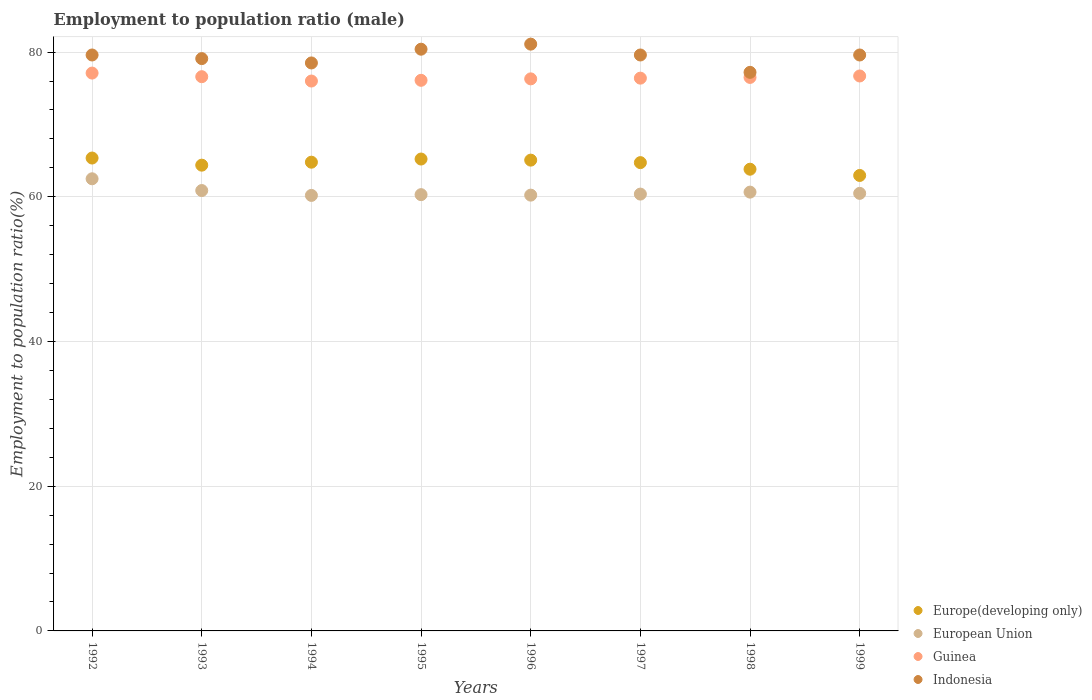How many different coloured dotlines are there?
Provide a succinct answer. 4. What is the employment to population ratio in European Union in 1994?
Your answer should be compact. 60.19. Across all years, what is the maximum employment to population ratio in Indonesia?
Your answer should be compact. 81.1. Across all years, what is the minimum employment to population ratio in Guinea?
Give a very brief answer. 76. In which year was the employment to population ratio in Indonesia minimum?
Ensure brevity in your answer.  1998. What is the total employment to population ratio in Europe(developing only) in the graph?
Keep it short and to the point. 516.29. What is the difference between the employment to population ratio in Indonesia in 1992 and the employment to population ratio in Europe(developing only) in 1997?
Give a very brief answer. 14.88. What is the average employment to population ratio in European Union per year?
Offer a very short reply. 60.7. In the year 1999, what is the difference between the employment to population ratio in Indonesia and employment to population ratio in Europe(developing only)?
Make the answer very short. 16.65. What is the ratio of the employment to population ratio in European Union in 1992 to that in 1995?
Make the answer very short. 1.04. Is the employment to population ratio in Guinea in 1996 less than that in 1998?
Keep it short and to the point. Yes. What is the difference between the highest and the second highest employment to population ratio in Guinea?
Your answer should be compact. 0.4. What is the difference between the highest and the lowest employment to population ratio in Guinea?
Provide a short and direct response. 1.1. Is the sum of the employment to population ratio in Guinea in 1995 and 1996 greater than the maximum employment to population ratio in Indonesia across all years?
Keep it short and to the point. Yes. Is it the case that in every year, the sum of the employment to population ratio in Europe(developing only) and employment to population ratio in Indonesia  is greater than the employment to population ratio in Guinea?
Provide a succinct answer. Yes. Does the employment to population ratio in Europe(developing only) monotonically increase over the years?
Make the answer very short. No. Is the employment to population ratio in European Union strictly greater than the employment to population ratio in Indonesia over the years?
Your answer should be very brief. No. Is the employment to population ratio in Guinea strictly less than the employment to population ratio in Indonesia over the years?
Ensure brevity in your answer.  Yes. What is the difference between two consecutive major ticks on the Y-axis?
Your answer should be compact. 20. Where does the legend appear in the graph?
Your answer should be very brief. Bottom right. What is the title of the graph?
Make the answer very short. Employment to population ratio (male). What is the label or title of the X-axis?
Keep it short and to the point. Years. What is the Employment to population ratio(%) of Europe(developing only) in 1992?
Provide a succinct answer. 65.36. What is the Employment to population ratio(%) in European Union in 1992?
Make the answer very short. 62.49. What is the Employment to population ratio(%) of Guinea in 1992?
Keep it short and to the point. 77.1. What is the Employment to population ratio(%) in Indonesia in 1992?
Your answer should be very brief. 79.6. What is the Employment to population ratio(%) in Europe(developing only) in 1993?
Your answer should be very brief. 64.37. What is the Employment to population ratio(%) in European Union in 1993?
Your answer should be very brief. 60.87. What is the Employment to population ratio(%) of Guinea in 1993?
Give a very brief answer. 76.6. What is the Employment to population ratio(%) of Indonesia in 1993?
Provide a succinct answer. 79.1. What is the Employment to population ratio(%) in Europe(developing only) in 1994?
Provide a succinct answer. 64.78. What is the Employment to population ratio(%) of European Union in 1994?
Your response must be concise. 60.19. What is the Employment to population ratio(%) in Indonesia in 1994?
Offer a terse response. 78.5. What is the Employment to population ratio(%) in Europe(developing only) in 1995?
Offer a very short reply. 65.22. What is the Employment to population ratio(%) of European Union in 1995?
Your answer should be very brief. 60.3. What is the Employment to population ratio(%) in Guinea in 1995?
Ensure brevity in your answer.  76.1. What is the Employment to population ratio(%) in Indonesia in 1995?
Provide a succinct answer. 80.4. What is the Employment to population ratio(%) of Europe(developing only) in 1996?
Provide a short and direct response. 65.07. What is the Employment to population ratio(%) of European Union in 1996?
Your answer should be very brief. 60.23. What is the Employment to population ratio(%) of Guinea in 1996?
Offer a very short reply. 76.3. What is the Employment to population ratio(%) in Indonesia in 1996?
Keep it short and to the point. 81.1. What is the Employment to population ratio(%) in Europe(developing only) in 1997?
Your answer should be compact. 64.72. What is the Employment to population ratio(%) in European Union in 1997?
Offer a very short reply. 60.37. What is the Employment to population ratio(%) of Guinea in 1997?
Provide a succinct answer. 76.4. What is the Employment to population ratio(%) in Indonesia in 1997?
Keep it short and to the point. 79.6. What is the Employment to population ratio(%) of Europe(developing only) in 1998?
Your answer should be compact. 63.81. What is the Employment to population ratio(%) in European Union in 1998?
Offer a very short reply. 60.65. What is the Employment to population ratio(%) of Guinea in 1998?
Provide a short and direct response. 76.5. What is the Employment to population ratio(%) of Indonesia in 1998?
Provide a succinct answer. 77.2. What is the Employment to population ratio(%) in Europe(developing only) in 1999?
Provide a succinct answer. 62.95. What is the Employment to population ratio(%) in European Union in 1999?
Provide a short and direct response. 60.48. What is the Employment to population ratio(%) of Guinea in 1999?
Your answer should be very brief. 76.7. What is the Employment to population ratio(%) of Indonesia in 1999?
Offer a terse response. 79.6. Across all years, what is the maximum Employment to population ratio(%) in Europe(developing only)?
Give a very brief answer. 65.36. Across all years, what is the maximum Employment to population ratio(%) in European Union?
Give a very brief answer. 62.49. Across all years, what is the maximum Employment to population ratio(%) in Guinea?
Provide a succinct answer. 77.1. Across all years, what is the maximum Employment to population ratio(%) in Indonesia?
Make the answer very short. 81.1. Across all years, what is the minimum Employment to population ratio(%) of Europe(developing only)?
Your response must be concise. 62.95. Across all years, what is the minimum Employment to population ratio(%) in European Union?
Provide a short and direct response. 60.19. Across all years, what is the minimum Employment to population ratio(%) in Guinea?
Give a very brief answer. 76. Across all years, what is the minimum Employment to population ratio(%) in Indonesia?
Offer a very short reply. 77.2. What is the total Employment to population ratio(%) in Europe(developing only) in the graph?
Your response must be concise. 516.29. What is the total Employment to population ratio(%) in European Union in the graph?
Give a very brief answer. 485.58. What is the total Employment to population ratio(%) of Guinea in the graph?
Provide a succinct answer. 611.7. What is the total Employment to population ratio(%) in Indonesia in the graph?
Give a very brief answer. 635.1. What is the difference between the Employment to population ratio(%) in European Union in 1992 and that in 1993?
Give a very brief answer. 1.62. What is the difference between the Employment to population ratio(%) of Indonesia in 1992 and that in 1993?
Ensure brevity in your answer.  0.5. What is the difference between the Employment to population ratio(%) of Europe(developing only) in 1992 and that in 1994?
Your answer should be very brief. 0.57. What is the difference between the Employment to population ratio(%) of European Union in 1992 and that in 1994?
Your response must be concise. 2.3. What is the difference between the Employment to population ratio(%) of Indonesia in 1992 and that in 1994?
Ensure brevity in your answer.  1.1. What is the difference between the Employment to population ratio(%) of Europe(developing only) in 1992 and that in 1995?
Provide a short and direct response. 0.14. What is the difference between the Employment to population ratio(%) in European Union in 1992 and that in 1995?
Your response must be concise. 2.19. What is the difference between the Employment to population ratio(%) of Europe(developing only) in 1992 and that in 1996?
Give a very brief answer. 0.29. What is the difference between the Employment to population ratio(%) in European Union in 1992 and that in 1996?
Provide a short and direct response. 2.26. What is the difference between the Employment to population ratio(%) in Guinea in 1992 and that in 1996?
Keep it short and to the point. 0.8. What is the difference between the Employment to population ratio(%) in Europe(developing only) in 1992 and that in 1997?
Provide a short and direct response. 0.63. What is the difference between the Employment to population ratio(%) of European Union in 1992 and that in 1997?
Offer a very short reply. 2.12. What is the difference between the Employment to population ratio(%) of Indonesia in 1992 and that in 1997?
Provide a succinct answer. 0. What is the difference between the Employment to population ratio(%) of Europe(developing only) in 1992 and that in 1998?
Keep it short and to the point. 1.54. What is the difference between the Employment to population ratio(%) in European Union in 1992 and that in 1998?
Your answer should be very brief. 1.84. What is the difference between the Employment to population ratio(%) of Guinea in 1992 and that in 1998?
Your answer should be compact. 0.6. What is the difference between the Employment to population ratio(%) in Indonesia in 1992 and that in 1998?
Your answer should be very brief. 2.4. What is the difference between the Employment to population ratio(%) of Europe(developing only) in 1992 and that in 1999?
Offer a very short reply. 2.41. What is the difference between the Employment to population ratio(%) of European Union in 1992 and that in 1999?
Give a very brief answer. 2.01. What is the difference between the Employment to population ratio(%) of Europe(developing only) in 1993 and that in 1994?
Keep it short and to the point. -0.41. What is the difference between the Employment to population ratio(%) in European Union in 1993 and that in 1994?
Offer a very short reply. 0.67. What is the difference between the Employment to population ratio(%) of Europe(developing only) in 1993 and that in 1995?
Provide a short and direct response. -0.85. What is the difference between the Employment to population ratio(%) of European Union in 1993 and that in 1995?
Offer a very short reply. 0.57. What is the difference between the Employment to population ratio(%) of Indonesia in 1993 and that in 1995?
Keep it short and to the point. -1.3. What is the difference between the Employment to population ratio(%) of Europe(developing only) in 1993 and that in 1996?
Give a very brief answer. -0.7. What is the difference between the Employment to population ratio(%) in European Union in 1993 and that in 1996?
Offer a very short reply. 0.63. What is the difference between the Employment to population ratio(%) of Guinea in 1993 and that in 1996?
Make the answer very short. 0.3. What is the difference between the Employment to population ratio(%) of Europe(developing only) in 1993 and that in 1997?
Provide a succinct answer. -0.35. What is the difference between the Employment to population ratio(%) in European Union in 1993 and that in 1997?
Provide a short and direct response. 0.49. What is the difference between the Employment to population ratio(%) in Guinea in 1993 and that in 1997?
Keep it short and to the point. 0.2. What is the difference between the Employment to population ratio(%) of Europe(developing only) in 1993 and that in 1998?
Provide a short and direct response. 0.56. What is the difference between the Employment to population ratio(%) in European Union in 1993 and that in 1998?
Your answer should be very brief. 0.22. What is the difference between the Employment to population ratio(%) of Guinea in 1993 and that in 1998?
Ensure brevity in your answer.  0.1. What is the difference between the Employment to population ratio(%) of Indonesia in 1993 and that in 1998?
Your response must be concise. 1.9. What is the difference between the Employment to population ratio(%) of Europe(developing only) in 1993 and that in 1999?
Give a very brief answer. 1.42. What is the difference between the Employment to population ratio(%) of European Union in 1993 and that in 1999?
Ensure brevity in your answer.  0.39. What is the difference between the Employment to population ratio(%) in Guinea in 1993 and that in 1999?
Your answer should be very brief. -0.1. What is the difference between the Employment to population ratio(%) of Europe(developing only) in 1994 and that in 1995?
Keep it short and to the point. -0.44. What is the difference between the Employment to population ratio(%) of European Union in 1994 and that in 1995?
Provide a short and direct response. -0.1. What is the difference between the Employment to population ratio(%) in Guinea in 1994 and that in 1995?
Ensure brevity in your answer.  -0.1. What is the difference between the Employment to population ratio(%) in Indonesia in 1994 and that in 1995?
Offer a very short reply. -1.9. What is the difference between the Employment to population ratio(%) in Europe(developing only) in 1994 and that in 1996?
Your response must be concise. -0.29. What is the difference between the Employment to population ratio(%) of European Union in 1994 and that in 1996?
Provide a succinct answer. -0.04. What is the difference between the Employment to population ratio(%) of Guinea in 1994 and that in 1996?
Provide a short and direct response. -0.3. What is the difference between the Employment to population ratio(%) in Indonesia in 1994 and that in 1996?
Keep it short and to the point. -2.6. What is the difference between the Employment to population ratio(%) of Europe(developing only) in 1994 and that in 1997?
Give a very brief answer. 0.06. What is the difference between the Employment to population ratio(%) in European Union in 1994 and that in 1997?
Offer a very short reply. -0.18. What is the difference between the Employment to population ratio(%) in Guinea in 1994 and that in 1997?
Offer a very short reply. -0.4. What is the difference between the Employment to population ratio(%) of Indonesia in 1994 and that in 1997?
Ensure brevity in your answer.  -1.1. What is the difference between the Employment to population ratio(%) of Europe(developing only) in 1994 and that in 1998?
Make the answer very short. 0.97. What is the difference between the Employment to population ratio(%) in European Union in 1994 and that in 1998?
Make the answer very short. -0.45. What is the difference between the Employment to population ratio(%) of Indonesia in 1994 and that in 1998?
Make the answer very short. 1.3. What is the difference between the Employment to population ratio(%) in Europe(developing only) in 1994 and that in 1999?
Your answer should be very brief. 1.83. What is the difference between the Employment to population ratio(%) of European Union in 1994 and that in 1999?
Offer a terse response. -0.28. What is the difference between the Employment to population ratio(%) in Guinea in 1994 and that in 1999?
Provide a succinct answer. -0.7. What is the difference between the Employment to population ratio(%) of Indonesia in 1994 and that in 1999?
Offer a terse response. -1.1. What is the difference between the Employment to population ratio(%) of Europe(developing only) in 1995 and that in 1996?
Offer a terse response. 0.15. What is the difference between the Employment to population ratio(%) of European Union in 1995 and that in 1996?
Your answer should be compact. 0.07. What is the difference between the Employment to population ratio(%) in Guinea in 1995 and that in 1996?
Offer a very short reply. -0.2. What is the difference between the Employment to population ratio(%) of Europe(developing only) in 1995 and that in 1997?
Provide a succinct answer. 0.5. What is the difference between the Employment to population ratio(%) of European Union in 1995 and that in 1997?
Your answer should be very brief. -0.08. What is the difference between the Employment to population ratio(%) in Europe(developing only) in 1995 and that in 1998?
Offer a terse response. 1.41. What is the difference between the Employment to population ratio(%) of European Union in 1995 and that in 1998?
Your answer should be very brief. -0.35. What is the difference between the Employment to population ratio(%) of Guinea in 1995 and that in 1998?
Ensure brevity in your answer.  -0.4. What is the difference between the Employment to population ratio(%) in Indonesia in 1995 and that in 1998?
Your response must be concise. 3.2. What is the difference between the Employment to population ratio(%) in Europe(developing only) in 1995 and that in 1999?
Ensure brevity in your answer.  2.27. What is the difference between the Employment to population ratio(%) in European Union in 1995 and that in 1999?
Provide a short and direct response. -0.18. What is the difference between the Employment to population ratio(%) of Guinea in 1995 and that in 1999?
Provide a succinct answer. -0.6. What is the difference between the Employment to population ratio(%) of Europe(developing only) in 1996 and that in 1997?
Your answer should be very brief. 0.35. What is the difference between the Employment to population ratio(%) in European Union in 1996 and that in 1997?
Keep it short and to the point. -0.14. What is the difference between the Employment to population ratio(%) of Indonesia in 1996 and that in 1997?
Keep it short and to the point. 1.5. What is the difference between the Employment to population ratio(%) of Europe(developing only) in 1996 and that in 1998?
Your answer should be very brief. 1.26. What is the difference between the Employment to population ratio(%) in European Union in 1996 and that in 1998?
Your answer should be very brief. -0.42. What is the difference between the Employment to population ratio(%) of Europe(developing only) in 1996 and that in 1999?
Your response must be concise. 2.12. What is the difference between the Employment to population ratio(%) in European Union in 1996 and that in 1999?
Your response must be concise. -0.25. What is the difference between the Employment to population ratio(%) of Indonesia in 1996 and that in 1999?
Give a very brief answer. 1.5. What is the difference between the Employment to population ratio(%) in Europe(developing only) in 1997 and that in 1998?
Offer a terse response. 0.91. What is the difference between the Employment to population ratio(%) in European Union in 1997 and that in 1998?
Offer a very short reply. -0.27. What is the difference between the Employment to population ratio(%) of Europe(developing only) in 1997 and that in 1999?
Provide a short and direct response. 1.77. What is the difference between the Employment to population ratio(%) of European Union in 1997 and that in 1999?
Provide a succinct answer. -0.1. What is the difference between the Employment to population ratio(%) of Indonesia in 1997 and that in 1999?
Keep it short and to the point. 0. What is the difference between the Employment to population ratio(%) of Europe(developing only) in 1998 and that in 1999?
Your answer should be compact. 0.86. What is the difference between the Employment to population ratio(%) of European Union in 1998 and that in 1999?
Offer a very short reply. 0.17. What is the difference between the Employment to population ratio(%) in Guinea in 1998 and that in 1999?
Make the answer very short. -0.2. What is the difference between the Employment to population ratio(%) in Indonesia in 1998 and that in 1999?
Offer a terse response. -2.4. What is the difference between the Employment to population ratio(%) in Europe(developing only) in 1992 and the Employment to population ratio(%) in European Union in 1993?
Your response must be concise. 4.49. What is the difference between the Employment to population ratio(%) of Europe(developing only) in 1992 and the Employment to population ratio(%) of Guinea in 1993?
Your answer should be compact. -11.24. What is the difference between the Employment to population ratio(%) of Europe(developing only) in 1992 and the Employment to population ratio(%) of Indonesia in 1993?
Keep it short and to the point. -13.74. What is the difference between the Employment to population ratio(%) in European Union in 1992 and the Employment to population ratio(%) in Guinea in 1993?
Your answer should be compact. -14.11. What is the difference between the Employment to population ratio(%) of European Union in 1992 and the Employment to population ratio(%) of Indonesia in 1993?
Offer a terse response. -16.61. What is the difference between the Employment to population ratio(%) of Europe(developing only) in 1992 and the Employment to population ratio(%) of European Union in 1994?
Ensure brevity in your answer.  5.16. What is the difference between the Employment to population ratio(%) of Europe(developing only) in 1992 and the Employment to population ratio(%) of Guinea in 1994?
Offer a terse response. -10.64. What is the difference between the Employment to population ratio(%) of Europe(developing only) in 1992 and the Employment to population ratio(%) of Indonesia in 1994?
Offer a terse response. -13.14. What is the difference between the Employment to population ratio(%) in European Union in 1992 and the Employment to population ratio(%) in Guinea in 1994?
Your answer should be very brief. -13.51. What is the difference between the Employment to population ratio(%) in European Union in 1992 and the Employment to population ratio(%) in Indonesia in 1994?
Your answer should be compact. -16.01. What is the difference between the Employment to population ratio(%) in Guinea in 1992 and the Employment to population ratio(%) in Indonesia in 1994?
Make the answer very short. -1.4. What is the difference between the Employment to population ratio(%) of Europe(developing only) in 1992 and the Employment to population ratio(%) of European Union in 1995?
Give a very brief answer. 5.06. What is the difference between the Employment to population ratio(%) of Europe(developing only) in 1992 and the Employment to population ratio(%) of Guinea in 1995?
Provide a succinct answer. -10.74. What is the difference between the Employment to population ratio(%) of Europe(developing only) in 1992 and the Employment to population ratio(%) of Indonesia in 1995?
Offer a very short reply. -15.04. What is the difference between the Employment to population ratio(%) in European Union in 1992 and the Employment to population ratio(%) in Guinea in 1995?
Your response must be concise. -13.61. What is the difference between the Employment to population ratio(%) in European Union in 1992 and the Employment to population ratio(%) in Indonesia in 1995?
Keep it short and to the point. -17.91. What is the difference between the Employment to population ratio(%) in Guinea in 1992 and the Employment to population ratio(%) in Indonesia in 1995?
Your answer should be compact. -3.3. What is the difference between the Employment to population ratio(%) of Europe(developing only) in 1992 and the Employment to population ratio(%) of European Union in 1996?
Provide a succinct answer. 5.13. What is the difference between the Employment to population ratio(%) of Europe(developing only) in 1992 and the Employment to population ratio(%) of Guinea in 1996?
Offer a very short reply. -10.94. What is the difference between the Employment to population ratio(%) of Europe(developing only) in 1992 and the Employment to population ratio(%) of Indonesia in 1996?
Your answer should be compact. -15.74. What is the difference between the Employment to population ratio(%) of European Union in 1992 and the Employment to population ratio(%) of Guinea in 1996?
Make the answer very short. -13.81. What is the difference between the Employment to population ratio(%) of European Union in 1992 and the Employment to population ratio(%) of Indonesia in 1996?
Provide a short and direct response. -18.61. What is the difference between the Employment to population ratio(%) in Europe(developing only) in 1992 and the Employment to population ratio(%) in European Union in 1997?
Make the answer very short. 4.98. What is the difference between the Employment to population ratio(%) of Europe(developing only) in 1992 and the Employment to population ratio(%) of Guinea in 1997?
Provide a succinct answer. -11.04. What is the difference between the Employment to population ratio(%) of Europe(developing only) in 1992 and the Employment to population ratio(%) of Indonesia in 1997?
Your response must be concise. -14.24. What is the difference between the Employment to population ratio(%) in European Union in 1992 and the Employment to population ratio(%) in Guinea in 1997?
Offer a terse response. -13.91. What is the difference between the Employment to population ratio(%) in European Union in 1992 and the Employment to population ratio(%) in Indonesia in 1997?
Your answer should be compact. -17.11. What is the difference between the Employment to population ratio(%) of Europe(developing only) in 1992 and the Employment to population ratio(%) of European Union in 1998?
Keep it short and to the point. 4.71. What is the difference between the Employment to population ratio(%) in Europe(developing only) in 1992 and the Employment to population ratio(%) in Guinea in 1998?
Provide a succinct answer. -11.14. What is the difference between the Employment to population ratio(%) of Europe(developing only) in 1992 and the Employment to population ratio(%) of Indonesia in 1998?
Offer a very short reply. -11.84. What is the difference between the Employment to population ratio(%) of European Union in 1992 and the Employment to population ratio(%) of Guinea in 1998?
Give a very brief answer. -14.01. What is the difference between the Employment to population ratio(%) of European Union in 1992 and the Employment to population ratio(%) of Indonesia in 1998?
Keep it short and to the point. -14.71. What is the difference between the Employment to population ratio(%) in Guinea in 1992 and the Employment to population ratio(%) in Indonesia in 1998?
Provide a succinct answer. -0.1. What is the difference between the Employment to population ratio(%) in Europe(developing only) in 1992 and the Employment to population ratio(%) in European Union in 1999?
Ensure brevity in your answer.  4.88. What is the difference between the Employment to population ratio(%) in Europe(developing only) in 1992 and the Employment to population ratio(%) in Guinea in 1999?
Provide a short and direct response. -11.34. What is the difference between the Employment to population ratio(%) in Europe(developing only) in 1992 and the Employment to population ratio(%) in Indonesia in 1999?
Your answer should be compact. -14.24. What is the difference between the Employment to population ratio(%) in European Union in 1992 and the Employment to population ratio(%) in Guinea in 1999?
Provide a succinct answer. -14.21. What is the difference between the Employment to population ratio(%) in European Union in 1992 and the Employment to population ratio(%) in Indonesia in 1999?
Provide a short and direct response. -17.11. What is the difference between the Employment to population ratio(%) of Europe(developing only) in 1993 and the Employment to population ratio(%) of European Union in 1994?
Make the answer very short. 4.18. What is the difference between the Employment to population ratio(%) in Europe(developing only) in 1993 and the Employment to population ratio(%) in Guinea in 1994?
Give a very brief answer. -11.63. What is the difference between the Employment to population ratio(%) of Europe(developing only) in 1993 and the Employment to population ratio(%) of Indonesia in 1994?
Your answer should be very brief. -14.13. What is the difference between the Employment to population ratio(%) in European Union in 1993 and the Employment to population ratio(%) in Guinea in 1994?
Keep it short and to the point. -15.13. What is the difference between the Employment to population ratio(%) in European Union in 1993 and the Employment to population ratio(%) in Indonesia in 1994?
Provide a short and direct response. -17.63. What is the difference between the Employment to population ratio(%) of Guinea in 1993 and the Employment to population ratio(%) of Indonesia in 1994?
Keep it short and to the point. -1.9. What is the difference between the Employment to population ratio(%) in Europe(developing only) in 1993 and the Employment to population ratio(%) in European Union in 1995?
Give a very brief answer. 4.08. What is the difference between the Employment to population ratio(%) of Europe(developing only) in 1993 and the Employment to population ratio(%) of Guinea in 1995?
Provide a succinct answer. -11.73. What is the difference between the Employment to population ratio(%) of Europe(developing only) in 1993 and the Employment to population ratio(%) of Indonesia in 1995?
Your answer should be compact. -16.03. What is the difference between the Employment to population ratio(%) in European Union in 1993 and the Employment to population ratio(%) in Guinea in 1995?
Your response must be concise. -15.23. What is the difference between the Employment to population ratio(%) in European Union in 1993 and the Employment to population ratio(%) in Indonesia in 1995?
Give a very brief answer. -19.53. What is the difference between the Employment to population ratio(%) in Europe(developing only) in 1993 and the Employment to population ratio(%) in European Union in 1996?
Offer a terse response. 4.14. What is the difference between the Employment to population ratio(%) in Europe(developing only) in 1993 and the Employment to population ratio(%) in Guinea in 1996?
Make the answer very short. -11.93. What is the difference between the Employment to population ratio(%) of Europe(developing only) in 1993 and the Employment to population ratio(%) of Indonesia in 1996?
Provide a succinct answer. -16.73. What is the difference between the Employment to population ratio(%) in European Union in 1993 and the Employment to population ratio(%) in Guinea in 1996?
Make the answer very short. -15.43. What is the difference between the Employment to population ratio(%) of European Union in 1993 and the Employment to population ratio(%) of Indonesia in 1996?
Provide a succinct answer. -20.23. What is the difference between the Employment to population ratio(%) of Guinea in 1993 and the Employment to population ratio(%) of Indonesia in 1996?
Ensure brevity in your answer.  -4.5. What is the difference between the Employment to population ratio(%) in Europe(developing only) in 1993 and the Employment to population ratio(%) in European Union in 1997?
Your response must be concise. 4. What is the difference between the Employment to population ratio(%) of Europe(developing only) in 1993 and the Employment to population ratio(%) of Guinea in 1997?
Your answer should be very brief. -12.03. What is the difference between the Employment to population ratio(%) of Europe(developing only) in 1993 and the Employment to population ratio(%) of Indonesia in 1997?
Offer a very short reply. -15.23. What is the difference between the Employment to population ratio(%) of European Union in 1993 and the Employment to population ratio(%) of Guinea in 1997?
Provide a short and direct response. -15.53. What is the difference between the Employment to population ratio(%) in European Union in 1993 and the Employment to population ratio(%) in Indonesia in 1997?
Your response must be concise. -18.73. What is the difference between the Employment to population ratio(%) of Guinea in 1993 and the Employment to population ratio(%) of Indonesia in 1997?
Your answer should be compact. -3. What is the difference between the Employment to population ratio(%) in Europe(developing only) in 1993 and the Employment to population ratio(%) in European Union in 1998?
Your answer should be compact. 3.73. What is the difference between the Employment to population ratio(%) of Europe(developing only) in 1993 and the Employment to population ratio(%) of Guinea in 1998?
Keep it short and to the point. -12.13. What is the difference between the Employment to population ratio(%) in Europe(developing only) in 1993 and the Employment to population ratio(%) in Indonesia in 1998?
Provide a succinct answer. -12.83. What is the difference between the Employment to population ratio(%) in European Union in 1993 and the Employment to population ratio(%) in Guinea in 1998?
Your response must be concise. -15.63. What is the difference between the Employment to population ratio(%) of European Union in 1993 and the Employment to population ratio(%) of Indonesia in 1998?
Your response must be concise. -16.33. What is the difference between the Employment to population ratio(%) of Guinea in 1993 and the Employment to population ratio(%) of Indonesia in 1998?
Provide a short and direct response. -0.6. What is the difference between the Employment to population ratio(%) in Europe(developing only) in 1993 and the Employment to population ratio(%) in European Union in 1999?
Your answer should be very brief. 3.9. What is the difference between the Employment to population ratio(%) of Europe(developing only) in 1993 and the Employment to population ratio(%) of Guinea in 1999?
Ensure brevity in your answer.  -12.33. What is the difference between the Employment to population ratio(%) in Europe(developing only) in 1993 and the Employment to population ratio(%) in Indonesia in 1999?
Make the answer very short. -15.23. What is the difference between the Employment to population ratio(%) in European Union in 1993 and the Employment to population ratio(%) in Guinea in 1999?
Make the answer very short. -15.83. What is the difference between the Employment to population ratio(%) in European Union in 1993 and the Employment to population ratio(%) in Indonesia in 1999?
Keep it short and to the point. -18.73. What is the difference between the Employment to population ratio(%) of Europe(developing only) in 1994 and the Employment to population ratio(%) of European Union in 1995?
Make the answer very short. 4.49. What is the difference between the Employment to population ratio(%) in Europe(developing only) in 1994 and the Employment to population ratio(%) in Guinea in 1995?
Offer a terse response. -11.32. What is the difference between the Employment to population ratio(%) of Europe(developing only) in 1994 and the Employment to population ratio(%) of Indonesia in 1995?
Your response must be concise. -15.62. What is the difference between the Employment to population ratio(%) of European Union in 1994 and the Employment to population ratio(%) of Guinea in 1995?
Provide a short and direct response. -15.91. What is the difference between the Employment to population ratio(%) of European Union in 1994 and the Employment to population ratio(%) of Indonesia in 1995?
Give a very brief answer. -20.21. What is the difference between the Employment to population ratio(%) of Europe(developing only) in 1994 and the Employment to population ratio(%) of European Union in 1996?
Keep it short and to the point. 4.55. What is the difference between the Employment to population ratio(%) of Europe(developing only) in 1994 and the Employment to population ratio(%) of Guinea in 1996?
Provide a short and direct response. -11.52. What is the difference between the Employment to population ratio(%) of Europe(developing only) in 1994 and the Employment to population ratio(%) of Indonesia in 1996?
Give a very brief answer. -16.32. What is the difference between the Employment to population ratio(%) in European Union in 1994 and the Employment to population ratio(%) in Guinea in 1996?
Make the answer very short. -16.11. What is the difference between the Employment to population ratio(%) of European Union in 1994 and the Employment to population ratio(%) of Indonesia in 1996?
Provide a succinct answer. -20.91. What is the difference between the Employment to population ratio(%) in Guinea in 1994 and the Employment to population ratio(%) in Indonesia in 1996?
Your answer should be very brief. -5.1. What is the difference between the Employment to population ratio(%) in Europe(developing only) in 1994 and the Employment to population ratio(%) in European Union in 1997?
Your answer should be compact. 4.41. What is the difference between the Employment to population ratio(%) of Europe(developing only) in 1994 and the Employment to population ratio(%) of Guinea in 1997?
Give a very brief answer. -11.62. What is the difference between the Employment to population ratio(%) of Europe(developing only) in 1994 and the Employment to population ratio(%) of Indonesia in 1997?
Provide a short and direct response. -14.82. What is the difference between the Employment to population ratio(%) in European Union in 1994 and the Employment to population ratio(%) in Guinea in 1997?
Provide a short and direct response. -16.21. What is the difference between the Employment to population ratio(%) in European Union in 1994 and the Employment to population ratio(%) in Indonesia in 1997?
Offer a very short reply. -19.41. What is the difference between the Employment to population ratio(%) in Europe(developing only) in 1994 and the Employment to population ratio(%) in European Union in 1998?
Ensure brevity in your answer.  4.14. What is the difference between the Employment to population ratio(%) in Europe(developing only) in 1994 and the Employment to population ratio(%) in Guinea in 1998?
Your response must be concise. -11.72. What is the difference between the Employment to population ratio(%) of Europe(developing only) in 1994 and the Employment to population ratio(%) of Indonesia in 1998?
Your response must be concise. -12.42. What is the difference between the Employment to population ratio(%) of European Union in 1994 and the Employment to population ratio(%) of Guinea in 1998?
Provide a short and direct response. -16.31. What is the difference between the Employment to population ratio(%) of European Union in 1994 and the Employment to population ratio(%) of Indonesia in 1998?
Provide a succinct answer. -17.01. What is the difference between the Employment to population ratio(%) of Europe(developing only) in 1994 and the Employment to population ratio(%) of European Union in 1999?
Your answer should be compact. 4.31. What is the difference between the Employment to population ratio(%) in Europe(developing only) in 1994 and the Employment to population ratio(%) in Guinea in 1999?
Provide a succinct answer. -11.92. What is the difference between the Employment to population ratio(%) of Europe(developing only) in 1994 and the Employment to population ratio(%) of Indonesia in 1999?
Give a very brief answer. -14.82. What is the difference between the Employment to population ratio(%) in European Union in 1994 and the Employment to population ratio(%) in Guinea in 1999?
Make the answer very short. -16.51. What is the difference between the Employment to population ratio(%) in European Union in 1994 and the Employment to population ratio(%) in Indonesia in 1999?
Keep it short and to the point. -19.41. What is the difference between the Employment to population ratio(%) of Guinea in 1994 and the Employment to population ratio(%) of Indonesia in 1999?
Your answer should be compact. -3.6. What is the difference between the Employment to population ratio(%) in Europe(developing only) in 1995 and the Employment to population ratio(%) in European Union in 1996?
Your response must be concise. 4.99. What is the difference between the Employment to population ratio(%) of Europe(developing only) in 1995 and the Employment to population ratio(%) of Guinea in 1996?
Offer a very short reply. -11.08. What is the difference between the Employment to population ratio(%) in Europe(developing only) in 1995 and the Employment to population ratio(%) in Indonesia in 1996?
Make the answer very short. -15.88. What is the difference between the Employment to population ratio(%) in European Union in 1995 and the Employment to population ratio(%) in Guinea in 1996?
Ensure brevity in your answer.  -16. What is the difference between the Employment to population ratio(%) in European Union in 1995 and the Employment to population ratio(%) in Indonesia in 1996?
Ensure brevity in your answer.  -20.8. What is the difference between the Employment to population ratio(%) of Europe(developing only) in 1995 and the Employment to population ratio(%) of European Union in 1997?
Keep it short and to the point. 4.85. What is the difference between the Employment to population ratio(%) of Europe(developing only) in 1995 and the Employment to population ratio(%) of Guinea in 1997?
Provide a succinct answer. -11.18. What is the difference between the Employment to population ratio(%) of Europe(developing only) in 1995 and the Employment to population ratio(%) of Indonesia in 1997?
Give a very brief answer. -14.38. What is the difference between the Employment to population ratio(%) of European Union in 1995 and the Employment to population ratio(%) of Guinea in 1997?
Ensure brevity in your answer.  -16.1. What is the difference between the Employment to population ratio(%) in European Union in 1995 and the Employment to population ratio(%) in Indonesia in 1997?
Keep it short and to the point. -19.3. What is the difference between the Employment to population ratio(%) in Europe(developing only) in 1995 and the Employment to population ratio(%) in European Union in 1998?
Offer a very short reply. 4.57. What is the difference between the Employment to population ratio(%) of Europe(developing only) in 1995 and the Employment to population ratio(%) of Guinea in 1998?
Provide a succinct answer. -11.28. What is the difference between the Employment to population ratio(%) of Europe(developing only) in 1995 and the Employment to population ratio(%) of Indonesia in 1998?
Your answer should be very brief. -11.98. What is the difference between the Employment to population ratio(%) in European Union in 1995 and the Employment to population ratio(%) in Guinea in 1998?
Offer a very short reply. -16.2. What is the difference between the Employment to population ratio(%) of European Union in 1995 and the Employment to population ratio(%) of Indonesia in 1998?
Provide a succinct answer. -16.9. What is the difference between the Employment to population ratio(%) in Europe(developing only) in 1995 and the Employment to population ratio(%) in European Union in 1999?
Your answer should be compact. 4.74. What is the difference between the Employment to population ratio(%) of Europe(developing only) in 1995 and the Employment to population ratio(%) of Guinea in 1999?
Provide a short and direct response. -11.48. What is the difference between the Employment to population ratio(%) of Europe(developing only) in 1995 and the Employment to population ratio(%) of Indonesia in 1999?
Provide a succinct answer. -14.38. What is the difference between the Employment to population ratio(%) of European Union in 1995 and the Employment to population ratio(%) of Guinea in 1999?
Your answer should be very brief. -16.4. What is the difference between the Employment to population ratio(%) of European Union in 1995 and the Employment to population ratio(%) of Indonesia in 1999?
Keep it short and to the point. -19.3. What is the difference between the Employment to population ratio(%) of Europe(developing only) in 1996 and the Employment to population ratio(%) of European Union in 1997?
Offer a terse response. 4.69. What is the difference between the Employment to population ratio(%) in Europe(developing only) in 1996 and the Employment to population ratio(%) in Guinea in 1997?
Your answer should be compact. -11.33. What is the difference between the Employment to population ratio(%) of Europe(developing only) in 1996 and the Employment to population ratio(%) of Indonesia in 1997?
Your answer should be very brief. -14.53. What is the difference between the Employment to population ratio(%) of European Union in 1996 and the Employment to population ratio(%) of Guinea in 1997?
Your answer should be very brief. -16.17. What is the difference between the Employment to population ratio(%) in European Union in 1996 and the Employment to population ratio(%) in Indonesia in 1997?
Your response must be concise. -19.37. What is the difference between the Employment to population ratio(%) in Guinea in 1996 and the Employment to population ratio(%) in Indonesia in 1997?
Offer a terse response. -3.3. What is the difference between the Employment to population ratio(%) of Europe(developing only) in 1996 and the Employment to population ratio(%) of European Union in 1998?
Your response must be concise. 4.42. What is the difference between the Employment to population ratio(%) of Europe(developing only) in 1996 and the Employment to population ratio(%) of Guinea in 1998?
Ensure brevity in your answer.  -11.43. What is the difference between the Employment to population ratio(%) of Europe(developing only) in 1996 and the Employment to population ratio(%) of Indonesia in 1998?
Ensure brevity in your answer.  -12.13. What is the difference between the Employment to population ratio(%) in European Union in 1996 and the Employment to population ratio(%) in Guinea in 1998?
Provide a short and direct response. -16.27. What is the difference between the Employment to population ratio(%) of European Union in 1996 and the Employment to population ratio(%) of Indonesia in 1998?
Your response must be concise. -16.97. What is the difference between the Employment to population ratio(%) of Guinea in 1996 and the Employment to population ratio(%) of Indonesia in 1998?
Ensure brevity in your answer.  -0.9. What is the difference between the Employment to population ratio(%) of Europe(developing only) in 1996 and the Employment to population ratio(%) of European Union in 1999?
Provide a succinct answer. 4.59. What is the difference between the Employment to population ratio(%) of Europe(developing only) in 1996 and the Employment to population ratio(%) of Guinea in 1999?
Your answer should be compact. -11.63. What is the difference between the Employment to population ratio(%) of Europe(developing only) in 1996 and the Employment to population ratio(%) of Indonesia in 1999?
Ensure brevity in your answer.  -14.53. What is the difference between the Employment to population ratio(%) of European Union in 1996 and the Employment to population ratio(%) of Guinea in 1999?
Your response must be concise. -16.47. What is the difference between the Employment to population ratio(%) in European Union in 1996 and the Employment to population ratio(%) in Indonesia in 1999?
Offer a very short reply. -19.37. What is the difference between the Employment to population ratio(%) of Europe(developing only) in 1997 and the Employment to population ratio(%) of European Union in 1998?
Your answer should be compact. 4.08. What is the difference between the Employment to population ratio(%) of Europe(developing only) in 1997 and the Employment to population ratio(%) of Guinea in 1998?
Provide a succinct answer. -11.78. What is the difference between the Employment to population ratio(%) in Europe(developing only) in 1997 and the Employment to population ratio(%) in Indonesia in 1998?
Your answer should be very brief. -12.48. What is the difference between the Employment to population ratio(%) in European Union in 1997 and the Employment to population ratio(%) in Guinea in 1998?
Your answer should be compact. -16.13. What is the difference between the Employment to population ratio(%) of European Union in 1997 and the Employment to population ratio(%) of Indonesia in 1998?
Give a very brief answer. -16.83. What is the difference between the Employment to population ratio(%) in Guinea in 1997 and the Employment to population ratio(%) in Indonesia in 1998?
Offer a very short reply. -0.8. What is the difference between the Employment to population ratio(%) of Europe(developing only) in 1997 and the Employment to population ratio(%) of European Union in 1999?
Your answer should be very brief. 4.25. What is the difference between the Employment to population ratio(%) of Europe(developing only) in 1997 and the Employment to population ratio(%) of Guinea in 1999?
Provide a short and direct response. -11.98. What is the difference between the Employment to population ratio(%) in Europe(developing only) in 1997 and the Employment to population ratio(%) in Indonesia in 1999?
Your answer should be very brief. -14.88. What is the difference between the Employment to population ratio(%) in European Union in 1997 and the Employment to population ratio(%) in Guinea in 1999?
Ensure brevity in your answer.  -16.33. What is the difference between the Employment to population ratio(%) in European Union in 1997 and the Employment to population ratio(%) in Indonesia in 1999?
Provide a succinct answer. -19.23. What is the difference between the Employment to population ratio(%) in Guinea in 1997 and the Employment to population ratio(%) in Indonesia in 1999?
Make the answer very short. -3.2. What is the difference between the Employment to population ratio(%) of Europe(developing only) in 1998 and the Employment to population ratio(%) of European Union in 1999?
Provide a short and direct response. 3.34. What is the difference between the Employment to population ratio(%) of Europe(developing only) in 1998 and the Employment to population ratio(%) of Guinea in 1999?
Make the answer very short. -12.89. What is the difference between the Employment to population ratio(%) of Europe(developing only) in 1998 and the Employment to population ratio(%) of Indonesia in 1999?
Provide a succinct answer. -15.79. What is the difference between the Employment to population ratio(%) of European Union in 1998 and the Employment to population ratio(%) of Guinea in 1999?
Your response must be concise. -16.05. What is the difference between the Employment to population ratio(%) of European Union in 1998 and the Employment to population ratio(%) of Indonesia in 1999?
Give a very brief answer. -18.95. What is the difference between the Employment to population ratio(%) of Guinea in 1998 and the Employment to population ratio(%) of Indonesia in 1999?
Keep it short and to the point. -3.1. What is the average Employment to population ratio(%) in Europe(developing only) per year?
Provide a succinct answer. 64.54. What is the average Employment to population ratio(%) of European Union per year?
Provide a succinct answer. 60.7. What is the average Employment to population ratio(%) in Guinea per year?
Provide a succinct answer. 76.46. What is the average Employment to population ratio(%) of Indonesia per year?
Keep it short and to the point. 79.39. In the year 1992, what is the difference between the Employment to population ratio(%) of Europe(developing only) and Employment to population ratio(%) of European Union?
Make the answer very short. 2.87. In the year 1992, what is the difference between the Employment to population ratio(%) in Europe(developing only) and Employment to population ratio(%) in Guinea?
Provide a short and direct response. -11.74. In the year 1992, what is the difference between the Employment to population ratio(%) in Europe(developing only) and Employment to population ratio(%) in Indonesia?
Offer a terse response. -14.24. In the year 1992, what is the difference between the Employment to population ratio(%) of European Union and Employment to population ratio(%) of Guinea?
Your answer should be compact. -14.61. In the year 1992, what is the difference between the Employment to population ratio(%) of European Union and Employment to population ratio(%) of Indonesia?
Your response must be concise. -17.11. In the year 1993, what is the difference between the Employment to population ratio(%) of Europe(developing only) and Employment to population ratio(%) of European Union?
Your answer should be very brief. 3.51. In the year 1993, what is the difference between the Employment to population ratio(%) of Europe(developing only) and Employment to population ratio(%) of Guinea?
Your response must be concise. -12.23. In the year 1993, what is the difference between the Employment to population ratio(%) of Europe(developing only) and Employment to population ratio(%) of Indonesia?
Make the answer very short. -14.73. In the year 1993, what is the difference between the Employment to population ratio(%) of European Union and Employment to population ratio(%) of Guinea?
Give a very brief answer. -15.73. In the year 1993, what is the difference between the Employment to population ratio(%) of European Union and Employment to population ratio(%) of Indonesia?
Your response must be concise. -18.23. In the year 1993, what is the difference between the Employment to population ratio(%) of Guinea and Employment to population ratio(%) of Indonesia?
Give a very brief answer. -2.5. In the year 1994, what is the difference between the Employment to population ratio(%) of Europe(developing only) and Employment to population ratio(%) of European Union?
Ensure brevity in your answer.  4.59. In the year 1994, what is the difference between the Employment to population ratio(%) in Europe(developing only) and Employment to population ratio(%) in Guinea?
Give a very brief answer. -11.22. In the year 1994, what is the difference between the Employment to population ratio(%) of Europe(developing only) and Employment to population ratio(%) of Indonesia?
Offer a terse response. -13.72. In the year 1994, what is the difference between the Employment to population ratio(%) of European Union and Employment to population ratio(%) of Guinea?
Your answer should be very brief. -15.81. In the year 1994, what is the difference between the Employment to population ratio(%) of European Union and Employment to population ratio(%) of Indonesia?
Give a very brief answer. -18.31. In the year 1995, what is the difference between the Employment to population ratio(%) in Europe(developing only) and Employment to population ratio(%) in European Union?
Offer a very short reply. 4.92. In the year 1995, what is the difference between the Employment to population ratio(%) of Europe(developing only) and Employment to population ratio(%) of Guinea?
Give a very brief answer. -10.88. In the year 1995, what is the difference between the Employment to population ratio(%) in Europe(developing only) and Employment to population ratio(%) in Indonesia?
Your answer should be compact. -15.18. In the year 1995, what is the difference between the Employment to population ratio(%) of European Union and Employment to population ratio(%) of Guinea?
Your answer should be compact. -15.8. In the year 1995, what is the difference between the Employment to population ratio(%) in European Union and Employment to population ratio(%) in Indonesia?
Give a very brief answer. -20.1. In the year 1995, what is the difference between the Employment to population ratio(%) in Guinea and Employment to population ratio(%) in Indonesia?
Offer a very short reply. -4.3. In the year 1996, what is the difference between the Employment to population ratio(%) in Europe(developing only) and Employment to population ratio(%) in European Union?
Offer a very short reply. 4.84. In the year 1996, what is the difference between the Employment to population ratio(%) of Europe(developing only) and Employment to population ratio(%) of Guinea?
Your answer should be very brief. -11.23. In the year 1996, what is the difference between the Employment to population ratio(%) in Europe(developing only) and Employment to population ratio(%) in Indonesia?
Provide a succinct answer. -16.03. In the year 1996, what is the difference between the Employment to population ratio(%) of European Union and Employment to population ratio(%) of Guinea?
Make the answer very short. -16.07. In the year 1996, what is the difference between the Employment to population ratio(%) of European Union and Employment to population ratio(%) of Indonesia?
Your answer should be very brief. -20.87. In the year 1997, what is the difference between the Employment to population ratio(%) in Europe(developing only) and Employment to population ratio(%) in European Union?
Your response must be concise. 4.35. In the year 1997, what is the difference between the Employment to population ratio(%) of Europe(developing only) and Employment to population ratio(%) of Guinea?
Make the answer very short. -11.68. In the year 1997, what is the difference between the Employment to population ratio(%) in Europe(developing only) and Employment to population ratio(%) in Indonesia?
Make the answer very short. -14.88. In the year 1997, what is the difference between the Employment to population ratio(%) in European Union and Employment to population ratio(%) in Guinea?
Make the answer very short. -16.03. In the year 1997, what is the difference between the Employment to population ratio(%) in European Union and Employment to population ratio(%) in Indonesia?
Your response must be concise. -19.23. In the year 1997, what is the difference between the Employment to population ratio(%) of Guinea and Employment to population ratio(%) of Indonesia?
Ensure brevity in your answer.  -3.2. In the year 1998, what is the difference between the Employment to population ratio(%) in Europe(developing only) and Employment to population ratio(%) in European Union?
Offer a very short reply. 3.17. In the year 1998, what is the difference between the Employment to population ratio(%) of Europe(developing only) and Employment to population ratio(%) of Guinea?
Keep it short and to the point. -12.69. In the year 1998, what is the difference between the Employment to population ratio(%) of Europe(developing only) and Employment to population ratio(%) of Indonesia?
Make the answer very short. -13.39. In the year 1998, what is the difference between the Employment to population ratio(%) in European Union and Employment to population ratio(%) in Guinea?
Your response must be concise. -15.85. In the year 1998, what is the difference between the Employment to population ratio(%) of European Union and Employment to population ratio(%) of Indonesia?
Your response must be concise. -16.55. In the year 1998, what is the difference between the Employment to population ratio(%) in Guinea and Employment to population ratio(%) in Indonesia?
Keep it short and to the point. -0.7. In the year 1999, what is the difference between the Employment to population ratio(%) in Europe(developing only) and Employment to population ratio(%) in European Union?
Provide a short and direct response. 2.47. In the year 1999, what is the difference between the Employment to population ratio(%) in Europe(developing only) and Employment to population ratio(%) in Guinea?
Provide a short and direct response. -13.75. In the year 1999, what is the difference between the Employment to population ratio(%) in Europe(developing only) and Employment to population ratio(%) in Indonesia?
Ensure brevity in your answer.  -16.65. In the year 1999, what is the difference between the Employment to population ratio(%) of European Union and Employment to population ratio(%) of Guinea?
Keep it short and to the point. -16.22. In the year 1999, what is the difference between the Employment to population ratio(%) in European Union and Employment to population ratio(%) in Indonesia?
Your answer should be very brief. -19.12. What is the ratio of the Employment to population ratio(%) in Europe(developing only) in 1992 to that in 1993?
Your answer should be compact. 1.02. What is the ratio of the Employment to population ratio(%) in European Union in 1992 to that in 1993?
Your answer should be very brief. 1.03. What is the ratio of the Employment to population ratio(%) in Guinea in 1992 to that in 1993?
Provide a succinct answer. 1.01. What is the ratio of the Employment to population ratio(%) in Indonesia in 1992 to that in 1993?
Your answer should be very brief. 1.01. What is the ratio of the Employment to population ratio(%) of Europe(developing only) in 1992 to that in 1994?
Ensure brevity in your answer.  1.01. What is the ratio of the Employment to population ratio(%) of European Union in 1992 to that in 1994?
Give a very brief answer. 1.04. What is the ratio of the Employment to population ratio(%) in Guinea in 1992 to that in 1994?
Keep it short and to the point. 1.01. What is the ratio of the Employment to population ratio(%) of Indonesia in 1992 to that in 1994?
Offer a terse response. 1.01. What is the ratio of the Employment to population ratio(%) of European Union in 1992 to that in 1995?
Provide a succinct answer. 1.04. What is the ratio of the Employment to population ratio(%) in Guinea in 1992 to that in 1995?
Offer a terse response. 1.01. What is the ratio of the Employment to population ratio(%) in Indonesia in 1992 to that in 1995?
Provide a succinct answer. 0.99. What is the ratio of the Employment to population ratio(%) of European Union in 1992 to that in 1996?
Offer a terse response. 1.04. What is the ratio of the Employment to population ratio(%) in Guinea in 1992 to that in 1996?
Provide a succinct answer. 1.01. What is the ratio of the Employment to population ratio(%) in Indonesia in 1992 to that in 1996?
Provide a succinct answer. 0.98. What is the ratio of the Employment to population ratio(%) of Europe(developing only) in 1992 to that in 1997?
Your answer should be very brief. 1.01. What is the ratio of the Employment to population ratio(%) of European Union in 1992 to that in 1997?
Provide a succinct answer. 1.03. What is the ratio of the Employment to population ratio(%) of Guinea in 1992 to that in 1997?
Your answer should be very brief. 1.01. What is the ratio of the Employment to population ratio(%) in Europe(developing only) in 1992 to that in 1998?
Give a very brief answer. 1.02. What is the ratio of the Employment to population ratio(%) in European Union in 1992 to that in 1998?
Ensure brevity in your answer.  1.03. What is the ratio of the Employment to population ratio(%) in Indonesia in 1992 to that in 1998?
Ensure brevity in your answer.  1.03. What is the ratio of the Employment to population ratio(%) in Europe(developing only) in 1992 to that in 1999?
Make the answer very short. 1.04. What is the ratio of the Employment to population ratio(%) in Guinea in 1992 to that in 1999?
Offer a very short reply. 1.01. What is the ratio of the Employment to population ratio(%) in Indonesia in 1992 to that in 1999?
Offer a very short reply. 1. What is the ratio of the Employment to population ratio(%) of European Union in 1993 to that in 1994?
Offer a terse response. 1.01. What is the ratio of the Employment to population ratio(%) in Guinea in 1993 to that in 1994?
Make the answer very short. 1.01. What is the ratio of the Employment to population ratio(%) in Indonesia in 1993 to that in 1994?
Your answer should be compact. 1.01. What is the ratio of the Employment to population ratio(%) in Europe(developing only) in 1993 to that in 1995?
Your answer should be compact. 0.99. What is the ratio of the Employment to population ratio(%) of European Union in 1993 to that in 1995?
Provide a short and direct response. 1.01. What is the ratio of the Employment to population ratio(%) of Guinea in 1993 to that in 1995?
Ensure brevity in your answer.  1.01. What is the ratio of the Employment to population ratio(%) in Indonesia in 1993 to that in 1995?
Offer a very short reply. 0.98. What is the ratio of the Employment to population ratio(%) of Europe(developing only) in 1993 to that in 1996?
Offer a terse response. 0.99. What is the ratio of the Employment to population ratio(%) of European Union in 1993 to that in 1996?
Your response must be concise. 1.01. What is the ratio of the Employment to population ratio(%) in Guinea in 1993 to that in 1996?
Your response must be concise. 1. What is the ratio of the Employment to population ratio(%) of Indonesia in 1993 to that in 1996?
Make the answer very short. 0.98. What is the ratio of the Employment to population ratio(%) of European Union in 1993 to that in 1997?
Your answer should be compact. 1.01. What is the ratio of the Employment to population ratio(%) in Guinea in 1993 to that in 1997?
Offer a terse response. 1. What is the ratio of the Employment to population ratio(%) in Indonesia in 1993 to that in 1997?
Your response must be concise. 0.99. What is the ratio of the Employment to population ratio(%) in Europe(developing only) in 1993 to that in 1998?
Your answer should be very brief. 1.01. What is the ratio of the Employment to population ratio(%) of European Union in 1993 to that in 1998?
Provide a succinct answer. 1. What is the ratio of the Employment to population ratio(%) in Indonesia in 1993 to that in 1998?
Your answer should be very brief. 1.02. What is the ratio of the Employment to population ratio(%) of Europe(developing only) in 1993 to that in 1999?
Your response must be concise. 1.02. What is the ratio of the Employment to population ratio(%) of European Union in 1993 to that in 1999?
Provide a succinct answer. 1.01. What is the ratio of the Employment to population ratio(%) in Indonesia in 1993 to that in 1999?
Your answer should be compact. 0.99. What is the ratio of the Employment to population ratio(%) in European Union in 1994 to that in 1995?
Make the answer very short. 1. What is the ratio of the Employment to population ratio(%) of Guinea in 1994 to that in 1995?
Offer a very short reply. 1. What is the ratio of the Employment to population ratio(%) in Indonesia in 1994 to that in 1995?
Make the answer very short. 0.98. What is the ratio of the Employment to population ratio(%) in Indonesia in 1994 to that in 1996?
Ensure brevity in your answer.  0.97. What is the ratio of the Employment to population ratio(%) of European Union in 1994 to that in 1997?
Give a very brief answer. 1. What is the ratio of the Employment to population ratio(%) in Indonesia in 1994 to that in 1997?
Keep it short and to the point. 0.99. What is the ratio of the Employment to population ratio(%) of Europe(developing only) in 1994 to that in 1998?
Give a very brief answer. 1.02. What is the ratio of the Employment to population ratio(%) of Guinea in 1994 to that in 1998?
Provide a short and direct response. 0.99. What is the ratio of the Employment to population ratio(%) of Indonesia in 1994 to that in 1998?
Keep it short and to the point. 1.02. What is the ratio of the Employment to population ratio(%) of Europe(developing only) in 1994 to that in 1999?
Keep it short and to the point. 1.03. What is the ratio of the Employment to population ratio(%) of European Union in 1994 to that in 1999?
Your response must be concise. 1. What is the ratio of the Employment to population ratio(%) of Guinea in 1994 to that in 1999?
Your answer should be very brief. 0.99. What is the ratio of the Employment to population ratio(%) in Indonesia in 1994 to that in 1999?
Offer a terse response. 0.99. What is the ratio of the Employment to population ratio(%) of Guinea in 1995 to that in 1996?
Provide a short and direct response. 1. What is the ratio of the Employment to population ratio(%) in Indonesia in 1995 to that in 1996?
Your answer should be compact. 0.99. What is the ratio of the Employment to population ratio(%) of Europe(developing only) in 1995 to that in 1997?
Ensure brevity in your answer.  1.01. What is the ratio of the Employment to population ratio(%) in European Union in 1995 to that in 1997?
Keep it short and to the point. 1. What is the ratio of the Employment to population ratio(%) of Indonesia in 1995 to that in 1997?
Your answer should be very brief. 1.01. What is the ratio of the Employment to population ratio(%) in European Union in 1995 to that in 1998?
Give a very brief answer. 0.99. What is the ratio of the Employment to population ratio(%) in Indonesia in 1995 to that in 1998?
Provide a succinct answer. 1.04. What is the ratio of the Employment to population ratio(%) of Europe(developing only) in 1995 to that in 1999?
Ensure brevity in your answer.  1.04. What is the ratio of the Employment to population ratio(%) of European Union in 1995 to that in 1999?
Make the answer very short. 1. What is the ratio of the Employment to population ratio(%) of Guinea in 1995 to that in 1999?
Give a very brief answer. 0.99. What is the ratio of the Employment to population ratio(%) in Indonesia in 1996 to that in 1997?
Your response must be concise. 1.02. What is the ratio of the Employment to population ratio(%) in Europe(developing only) in 1996 to that in 1998?
Provide a succinct answer. 1.02. What is the ratio of the Employment to population ratio(%) in Guinea in 1996 to that in 1998?
Your answer should be very brief. 1. What is the ratio of the Employment to population ratio(%) in Indonesia in 1996 to that in 1998?
Ensure brevity in your answer.  1.05. What is the ratio of the Employment to population ratio(%) of Europe(developing only) in 1996 to that in 1999?
Ensure brevity in your answer.  1.03. What is the ratio of the Employment to population ratio(%) of European Union in 1996 to that in 1999?
Offer a very short reply. 1. What is the ratio of the Employment to population ratio(%) of Indonesia in 1996 to that in 1999?
Provide a short and direct response. 1.02. What is the ratio of the Employment to population ratio(%) of Europe(developing only) in 1997 to that in 1998?
Keep it short and to the point. 1.01. What is the ratio of the Employment to population ratio(%) of Guinea in 1997 to that in 1998?
Make the answer very short. 1. What is the ratio of the Employment to population ratio(%) in Indonesia in 1997 to that in 1998?
Your answer should be compact. 1.03. What is the ratio of the Employment to population ratio(%) in Europe(developing only) in 1997 to that in 1999?
Make the answer very short. 1.03. What is the ratio of the Employment to population ratio(%) in European Union in 1997 to that in 1999?
Keep it short and to the point. 1. What is the ratio of the Employment to population ratio(%) of Europe(developing only) in 1998 to that in 1999?
Ensure brevity in your answer.  1.01. What is the ratio of the Employment to population ratio(%) in Guinea in 1998 to that in 1999?
Make the answer very short. 1. What is the ratio of the Employment to population ratio(%) in Indonesia in 1998 to that in 1999?
Make the answer very short. 0.97. What is the difference between the highest and the second highest Employment to population ratio(%) of Europe(developing only)?
Provide a succinct answer. 0.14. What is the difference between the highest and the second highest Employment to population ratio(%) in European Union?
Provide a succinct answer. 1.62. What is the difference between the highest and the lowest Employment to population ratio(%) of Europe(developing only)?
Make the answer very short. 2.41. What is the difference between the highest and the lowest Employment to population ratio(%) of European Union?
Your answer should be compact. 2.3. What is the difference between the highest and the lowest Employment to population ratio(%) in Guinea?
Your answer should be very brief. 1.1. 